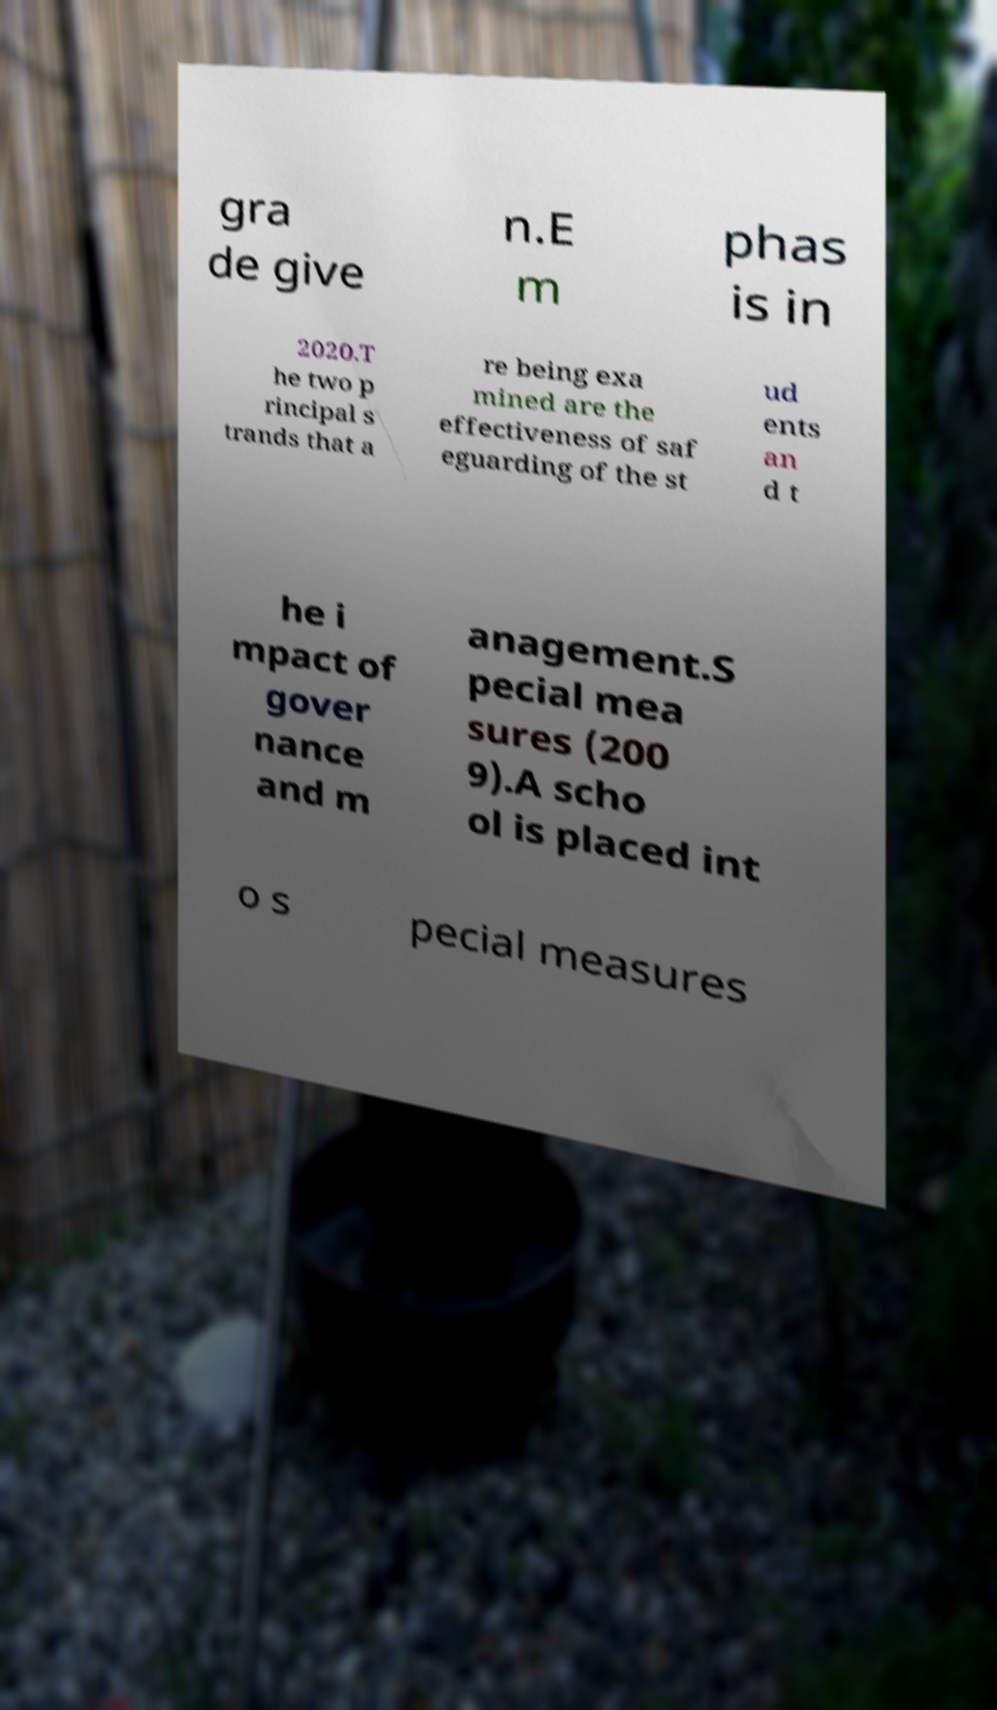Please identify and transcribe the text found in this image. gra de give n.E m phas is in 2020.T he two p rincipal s trands that a re being exa mined are the effectiveness of saf eguarding of the st ud ents an d t he i mpact of gover nance and m anagement.S pecial mea sures (200 9).A scho ol is placed int o s pecial measures 